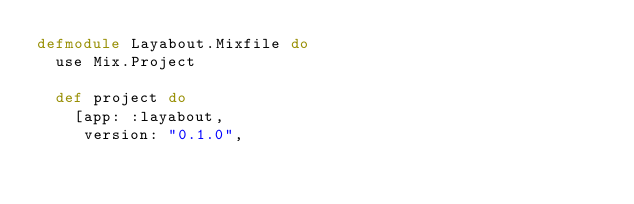<code> <loc_0><loc_0><loc_500><loc_500><_Elixir_>defmodule Layabout.Mixfile do
  use Mix.Project

  def project do
    [app: :layabout,
     version: "0.1.0",</code> 